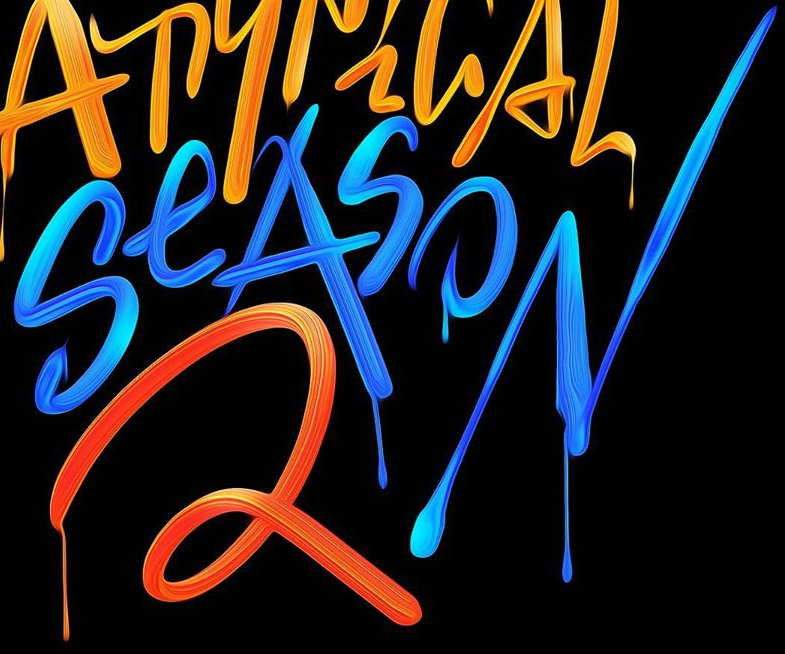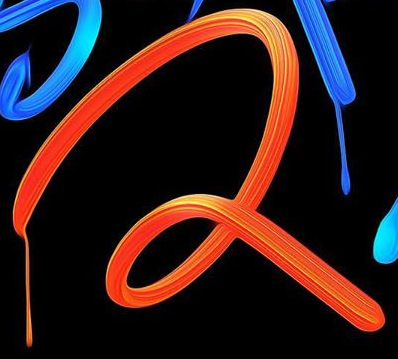What text appears in these images from left to right, separated by a semicolon? SeASON; 2 